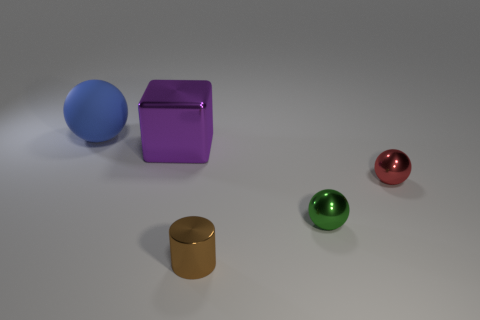There is a large object in front of the large object left of the large metal object; what is it made of?
Offer a terse response. Metal. Does the object on the right side of the small green metallic sphere have the same shape as the purple thing?
Your response must be concise. No. The tiny cylinder that is made of the same material as the green ball is what color?
Provide a succinct answer. Brown. What is the sphere that is on the left side of the small cylinder made of?
Keep it short and to the point. Rubber. Is the shape of the small red metallic thing the same as the tiny thing that is in front of the tiny green object?
Keep it short and to the point. No. There is a sphere that is both on the right side of the metal cylinder and behind the green metallic object; what material is it?
Offer a terse response. Metal. The matte ball that is the same size as the cube is what color?
Provide a succinct answer. Blue. Is the tiny red ball made of the same material as the big object that is on the right side of the large matte ball?
Your answer should be compact. Yes. How many other things are the same size as the blue matte ball?
Keep it short and to the point. 1. There is a large object on the right side of the thing that is behind the block; are there any red shiny things that are in front of it?
Provide a succinct answer. Yes. 